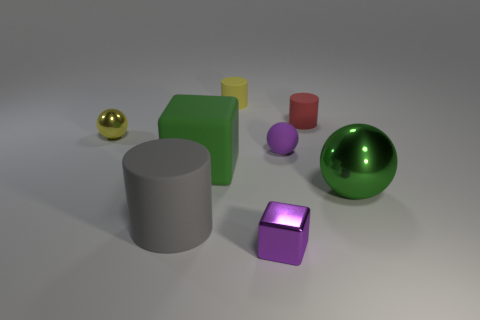Is there any other thing that has the same size as the matte cube?
Provide a succinct answer. Yes. There is a rubber thing that is both to the left of the tiny purple rubber ball and behind the small rubber ball; what is its size?
Make the answer very short. Small. There is a tiny purple thing that is made of the same material as the green ball; what is its shape?
Offer a terse response. Cube. Does the tiny purple block have the same material as the yellow object that is to the left of the big green matte object?
Ensure brevity in your answer.  Yes. There is a cylinder that is in front of the green metallic thing; is there a small yellow rubber cylinder that is behind it?
Ensure brevity in your answer.  Yes. What is the material of the large object that is the same shape as the small red rubber thing?
Provide a short and direct response. Rubber. What number of purple shiny objects are on the right side of the purple thing that is behind the big green rubber thing?
Offer a terse response. 0. Are there any other things of the same color as the large metal sphere?
Your answer should be compact. Yes. How many things are either small purple cubes or large matte things that are in front of the green ball?
Your answer should be very brief. 2. What material is the tiny purple thing in front of the big green object that is on the right side of the block in front of the large green metal sphere?
Offer a very short reply. Metal. 